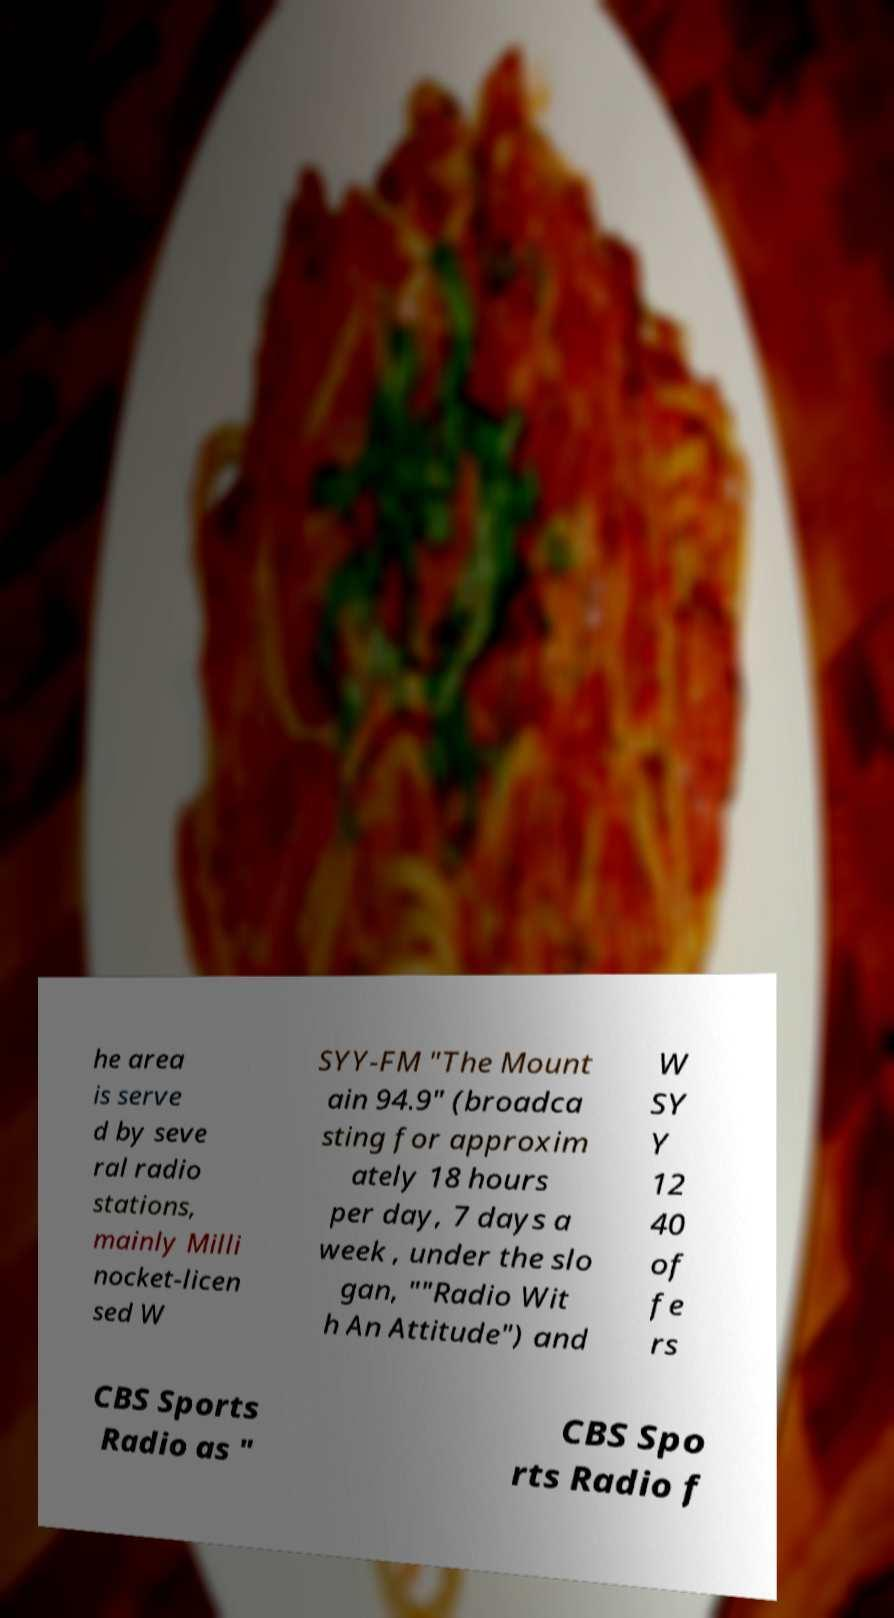Please identify and transcribe the text found in this image. he area is serve d by seve ral radio stations, mainly Milli nocket-licen sed W SYY-FM "The Mount ain 94.9" (broadca sting for approxim ately 18 hours per day, 7 days a week , under the slo gan, ""Radio Wit h An Attitude") and W SY Y 12 40 of fe rs CBS Sports Radio as " CBS Spo rts Radio f 